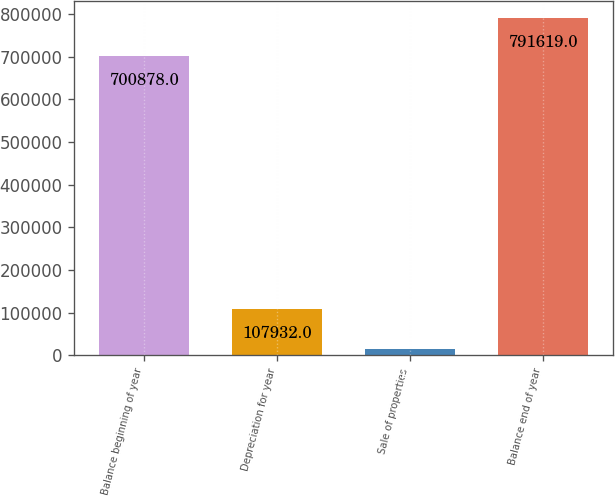Convert chart to OTSL. <chart><loc_0><loc_0><loc_500><loc_500><bar_chart><fcel>Balance beginning of year<fcel>Depreciation for year<fcel>Sale of properties<fcel>Balance end of year<nl><fcel>700878<fcel>107932<fcel>14101<fcel>791619<nl></chart> 